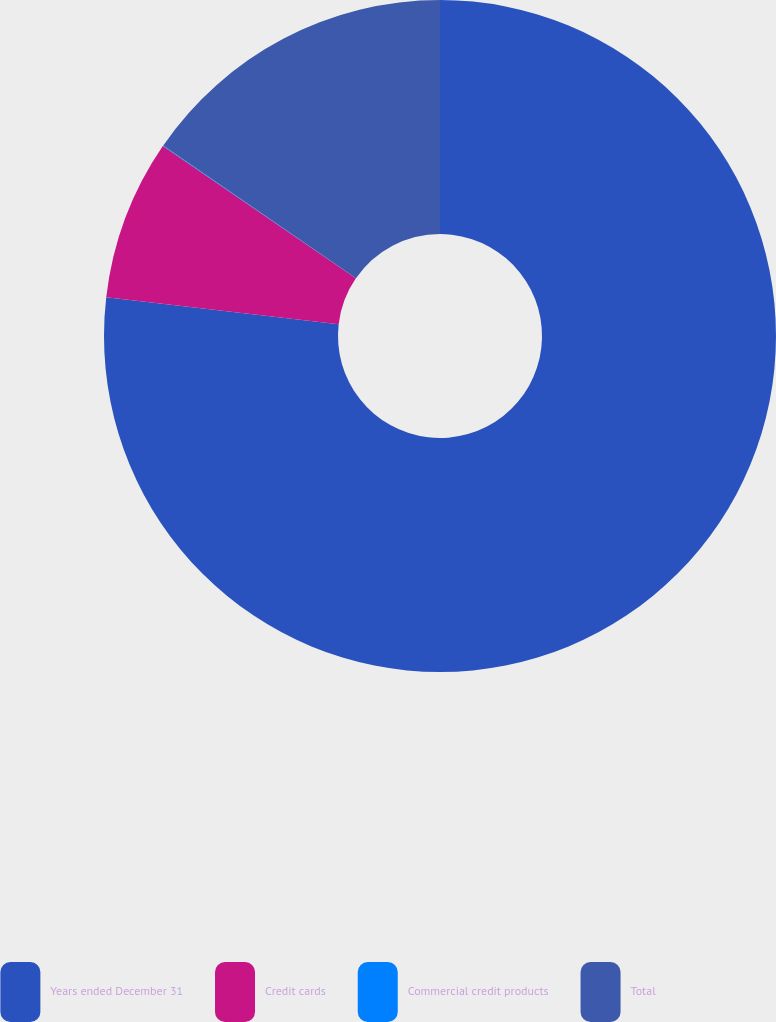Convert chart. <chart><loc_0><loc_0><loc_500><loc_500><pie_chart><fcel>Years ended December 31<fcel>Credit cards<fcel>Commercial credit products<fcel>Total<nl><fcel>76.84%<fcel>7.72%<fcel>0.04%<fcel>15.4%<nl></chart> 